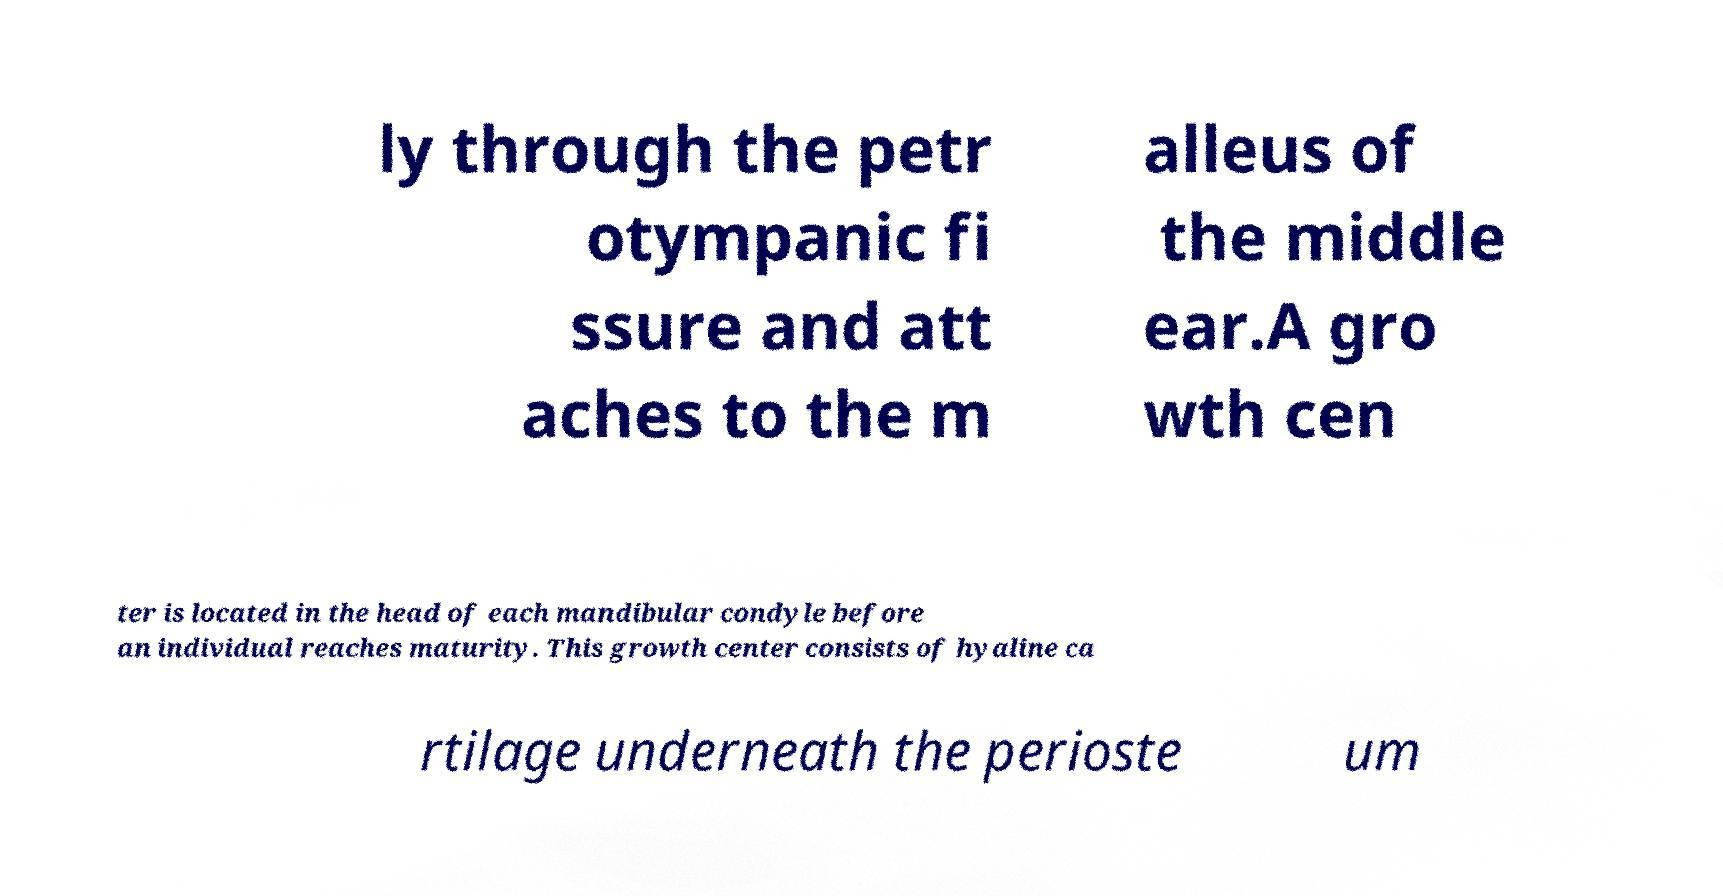Can you read and provide the text displayed in the image?This photo seems to have some interesting text. Can you extract and type it out for me? ly through the petr otympanic fi ssure and att aches to the m alleus of the middle ear.A gro wth cen ter is located in the head of each mandibular condyle before an individual reaches maturity. This growth center consists of hyaline ca rtilage underneath the perioste um 